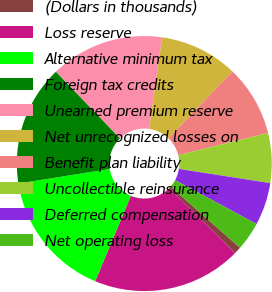Convert chart. <chart><loc_0><loc_0><loc_500><loc_500><pie_chart><fcel>(Dollars in thousands)<fcel>Loss reserve<fcel>Alternative minimum tax<fcel>Foreign tax credits<fcel>Unearned premium reserve<fcel>Net unrecognized losses on<fcel>Benefit plan liability<fcel>Uncollectible reinsurance<fcel>Deferred compensation<fcel>Net operating loss<nl><fcel>0.91%<fcel>18.91%<fcel>16.21%<fcel>15.31%<fcel>14.41%<fcel>9.91%<fcel>9.01%<fcel>6.31%<fcel>5.41%<fcel>3.61%<nl></chart> 